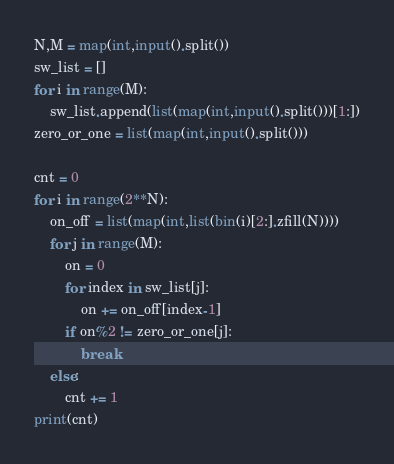<code> <loc_0><loc_0><loc_500><loc_500><_Python_>N,M = map(int,input().split())
sw_list = []
for i in range(M):
    sw_list.append(list(map(int,input().split()))[1:])
zero_or_one = list(map(int,input().split()))

cnt = 0
for i in range(2**N):
    on_off = list(map(int,list(bin(i)[2:].zfill(N))))
    for j in range(M):
        on = 0
        for index in sw_list[j]:
            on += on_off[index-1]
        if on%2 != zero_or_one[j]:
            break
    else:
        cnt += 1
print(cnt)</code> 